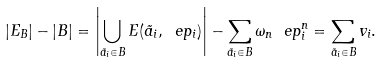Convert formula to latex. <formula><loc_0><loc_0><loc_500><loc_500>| E _ { B } | - | B | = \left | \bigcup _ { \vec { a } _ { i } \in B } E ( \vec { a } _ { i } , \ e p _ { i } ) \right | - \sum _ { \vec { a } _ { i } \in B } \omega _ { n } \ e p _ { i } ^ { n } = \sum _ { \vec { a } _ { i } \in B } v _ { i } .</formula> 